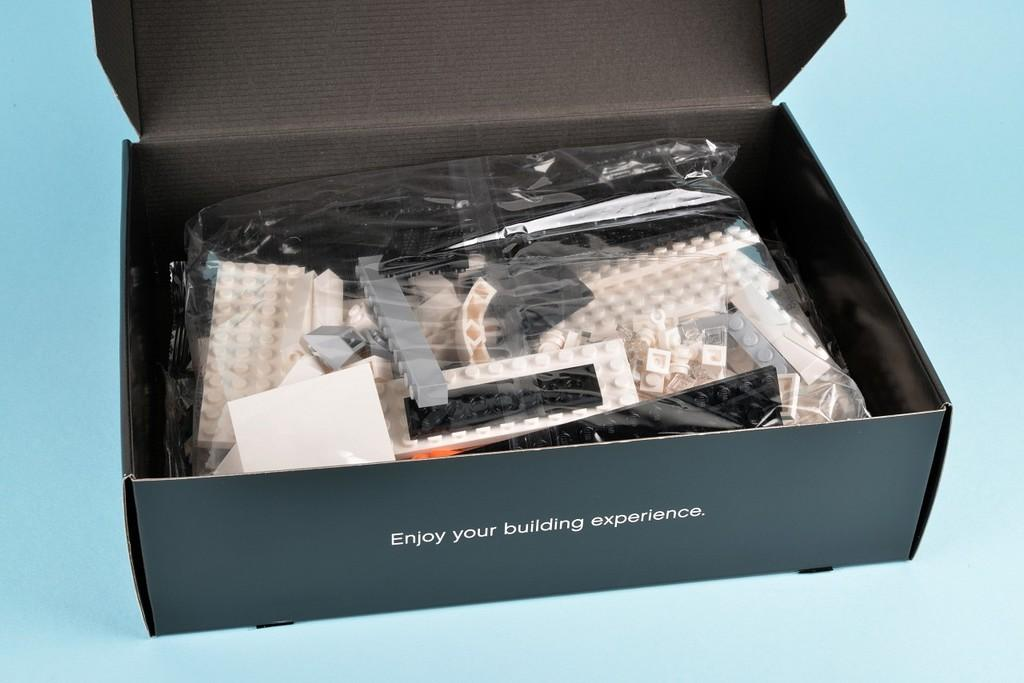<image>
Give a short and clear explanation of the subsequent image. A box of legos suggests to Enjoy your building experience. 